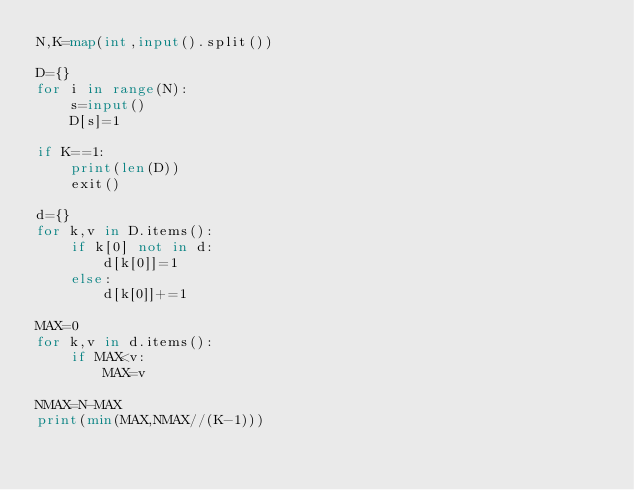Convert code to text. <code><loc_0><loc_0><loc_500><loc_500><_Python_>N,K=map(int,input().split())

D={}
for i in range(N):
    s=input()
    D[s]=1

if K==1:
    print(len(D))
    exit()

d={}
for k,v in D.items():
    if k[0] not in d:
        d[k[0]]=1
    else:
        d[k[0]]+=1

MAX=0
for k,v in d.items():
    if MAX<v:
        MAX=v

NMAX=N-MAX
print(min(MAX,NMAX//(K-1)))
</code> 